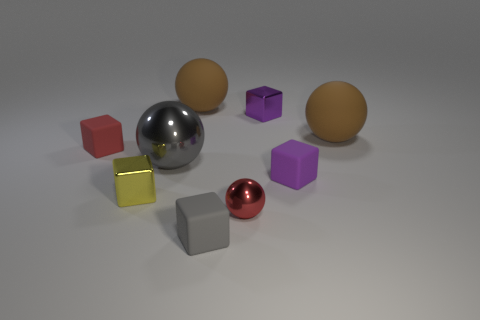Subtract all purple matte cubes. How many cubes are left? 4 Subtract all red blocks. How many blocks are left? 4 Subtract all cyan cubes. Subtract all purple balls. How many cubes are left? 5 Subtract all spheres. How many objects are left? 5 Subtract 1 red blocks. How many objects are left? 8 Subtract all rubber objects. Subtract all brown objects. How many objects are left? 2 Add 5 shiny objects. How many shiny objects are left? 9 Add 6 gray matte balls. How many gray matte balls exist? 6 